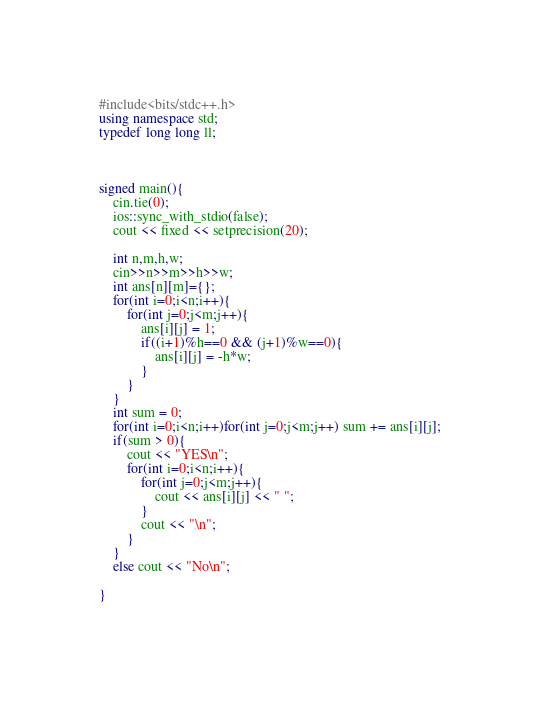Convert code to text. <code><loc_0><loc_0><loc_500><loc_500><_C++_>#include<bits/stdc++.h>
using namespace std;
typedef long long ll;



signed main(){
    cin.tie(0);
    ios::sync_with_stdio(false);
    cout << fixed << setprecision(20);
 
    int n,m,h,w;
    cin>>n>>m>>h>>w;
    int ans[n][m]={};
    for(int i=0;i<n;i++){
        for(int j=0;j<m;j++){
            ans[i][j] = 1;
            if((i+1)%h==0 && (j+1)%w==0){
                ans[i][j] = -h*w;
            }
        }
    }
    int sum = 0;
    for(int i=0;i<n;i++)for(int j=0;j<m;j++) sum += ans[i][j];
    if(sum > 0){
        cout << "YES\n";
        for(int i=0;i<n;i++){
            for(int j=0;j<m;j++){
                cout << ans[i][j] << " ";
            }
            cout << "\n";
        }
    }
    else cout << "No\n";
    
}</code> 